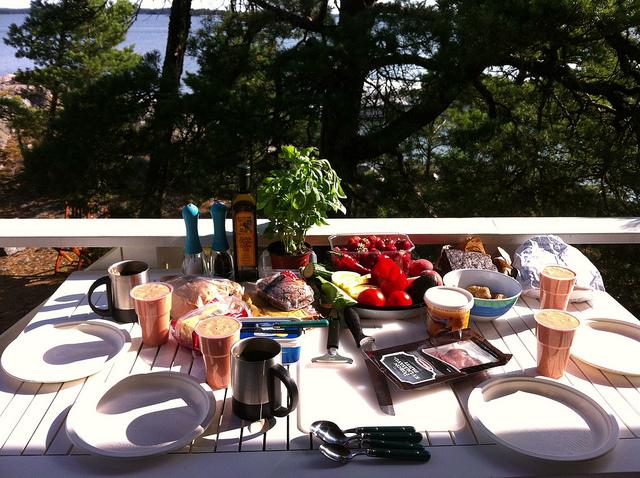Are the plates made of paper?
Concise answer only. Yes. How many cups are on the table?
Be succinct. 6. What city do you believe this photo was taken in?
Answer briefly. Los angeles. 